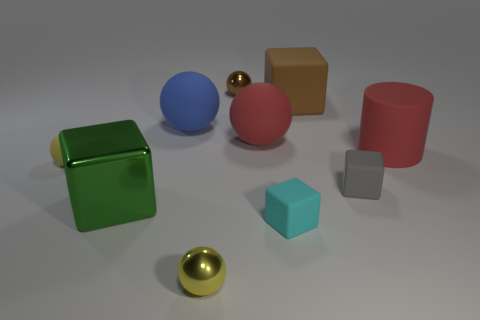Is the large shiny cube the same color as the cylinder? No, the large shiny cube is a vibrant green, whereas the cylinder appears to be a matte pink. Although their finishes and material properties differ—shiny for the cube and matte for the cylinder—this contrast is also prominent in their distinct colors. 